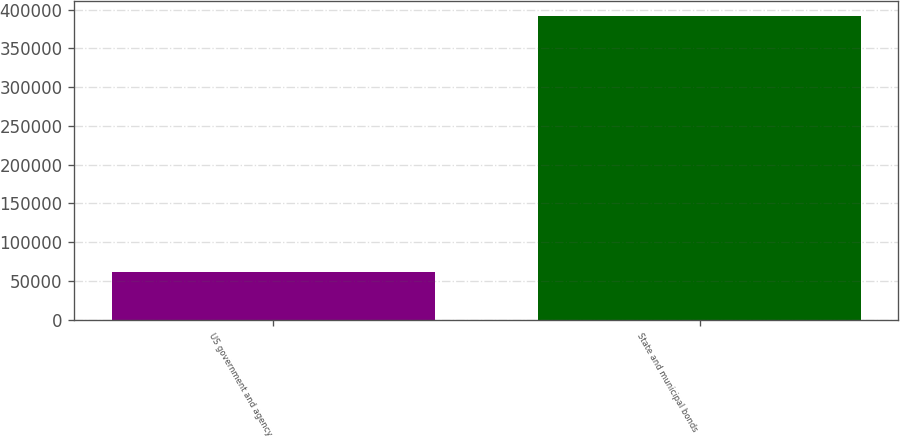Convert chart to OTSL. <chart><loc_0><loc_0><loc_500><loc_500><bar_chart><fcel>US government and agency<fcel>State and municipal bonds<nl><fcel>62011<fcel>391537<nl></chart> 